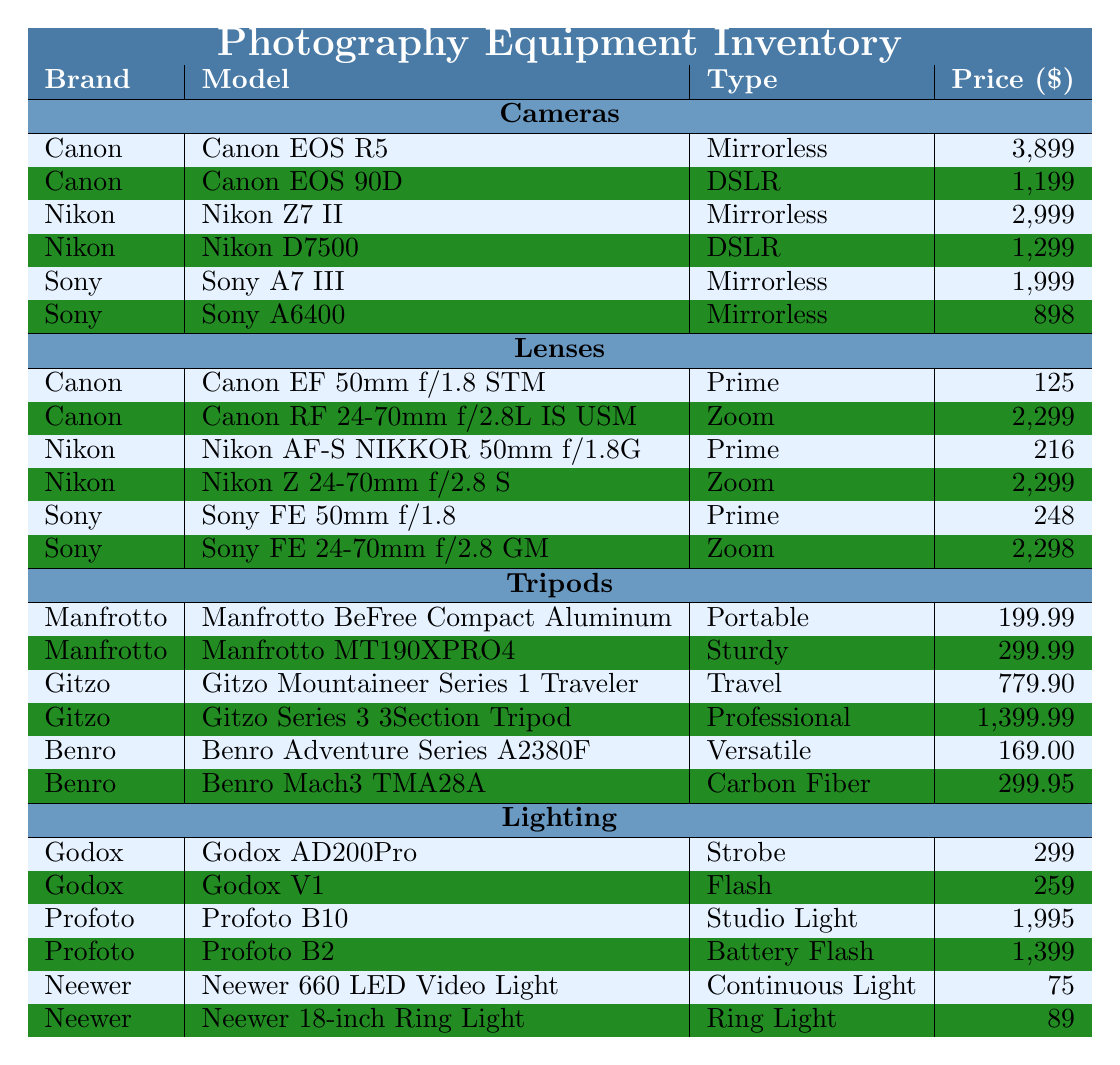What is the price of the Canon EOS R5? The model Canon EOS R5 is listed under the Canon brand in the Cameras section, and its price is shown as 3,899.
Answer: 3,899 How many different types of tripods are available in the inventory? The Tripods section lists three brands (Manfrotto, Gitzo, and Benro), and there are two models for each brand, resulting in a total of 6 tripod models.
Answer: 6 Which camera has the highest megapixels? Comparing the Megapixels of the listed cameras, the Canon EOS R5 has 45, Nikon Z7 II has 45.7, Canon EOS 90D has 32.5, Nikon D7500 has 20.9, Sony A7 III and A6400 both have 24.2. The highest is 45.7 (Nikon Z7 II).
Answer: 45.7 What is the most expensive lens by Sony? Under the Lenses section, Sony has two models: the Sony FE 50mm f/1.8 priced at 248 and the Sony FE 24-70mm f/2.8 GM priced at 2,298. The most expensive is the FE 24-70mm f/2.8 GM.
Answer: 2,298 Is the average price of Canon lenses higher than that of Nikon lenses? Canon lens prices are 125 and 2,299, averaging (125 + 2299) / 2 = 1212. The Nikon lens prices are 216 and 2,299, averaging (216 + 2299) / 2 = 1257. Since 1212 < 1257, Canon lenses are not more expensive on average.
Answer: No What is the total cost of all the lighting equipment listed? Adding the costs of all the lighting models: Godox AD200Pro (299) + Godox V1 (259) + Profoto B10 (1995) + Profoto B2 (1399) + Neewer 660 LED Video Light (75) + Neewer 18-inch Ring Light (89) gives us a total of 299 + 259 + 1995 + 1399 + 75 + 89 = 4116.
Answer: 4,116 Which brand offers a portable tripod? The Tripods section lists that Manfrotto offers the BeFree Compact Aluminum Tripod, categorized as Portable.
Answer: Manfrotto Are there any cameras with more than 40 megapixels? From the Cameras section, the Canon EOS R5 (45 MP), Nikon Z7 II (45.7 MP), and Nikon D7500 (20.9 MP) are compared. Thus, Canon EOS R5 and Nikon Z7 II are the only cameras over 40 megapixels.
Answer: Yes What is the difference in price between the cheapest and the most expensive tripod? The cheapest tripod is the Benro Adventure Series A2380F priced at 169.00 and the most expensive tripod is Gitzo Series 3 3-Section Tripod at 1399.99. Therefore, the difference is 1399.99 - 169.00 = 1230.99.
Answer: 1,230.99 What types of cameras are available from Sony? The Cameras section shows two Sony models: A7 III (Mirrorless) and A6400 (Mirrorless).
Answer: Mirrorless 